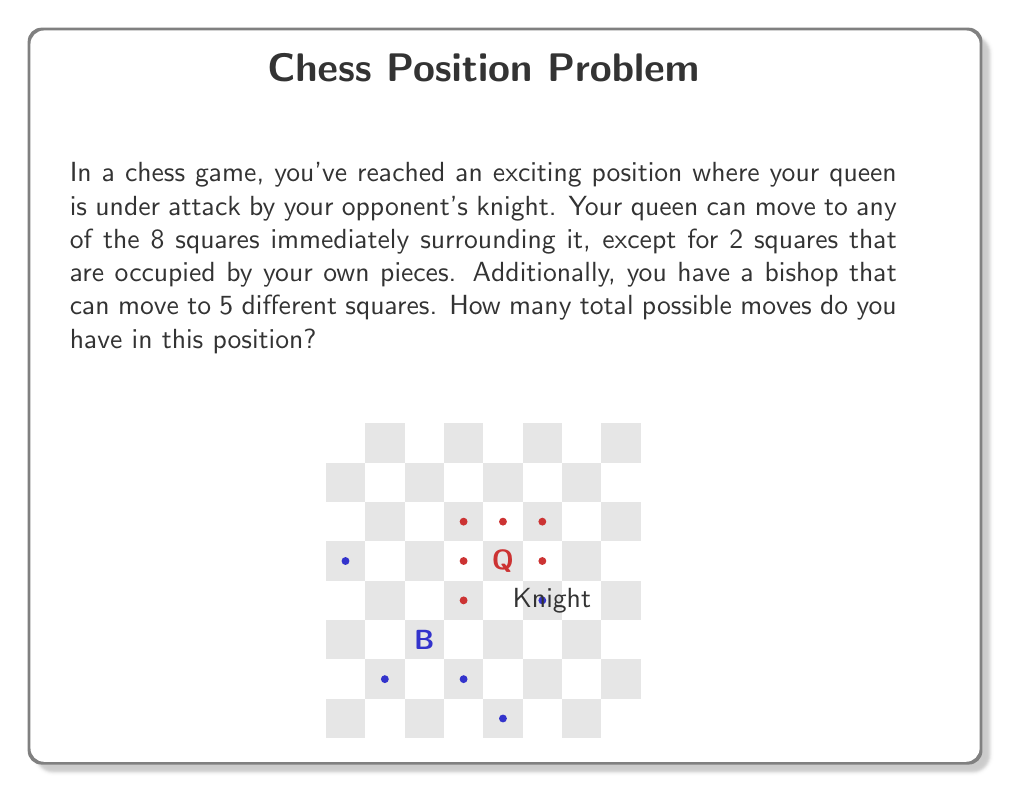Can you answer this question? Let's break this down step-by-step:

1) First, let's count the queen's possible moves:
   - The queen can normally move to 8 squares around it.
   - However, 2 of these squares are occupied by friendly pieces.
   - So, the queen has $8 - 2 = 6$ possible moves.

2) Now, let's count the bishop's possible moves:
   - We're told that the bishop can move to 5 different squares.

3) To find the total number of possible moves, we need to add the moves of both pieces:
   $$ \text{Total moves} = \text{Queen's moves} + \text{Bishop's moves} $$
   $$ \text{Total moves} = 6 + 5 = 11 $$

Therefore, you have 11 total possible moves in this position.
Answer: 11 moves 